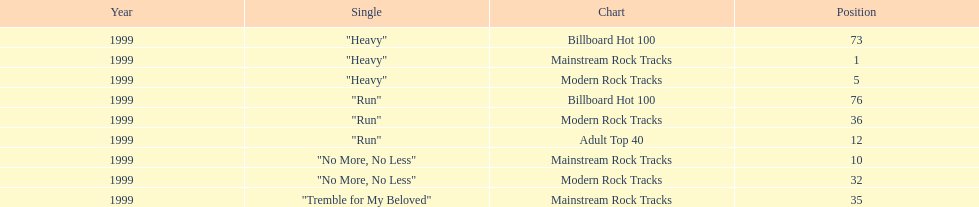How many tracks from the "dosage" album were listed on the modern rock tracks charts? 3. 